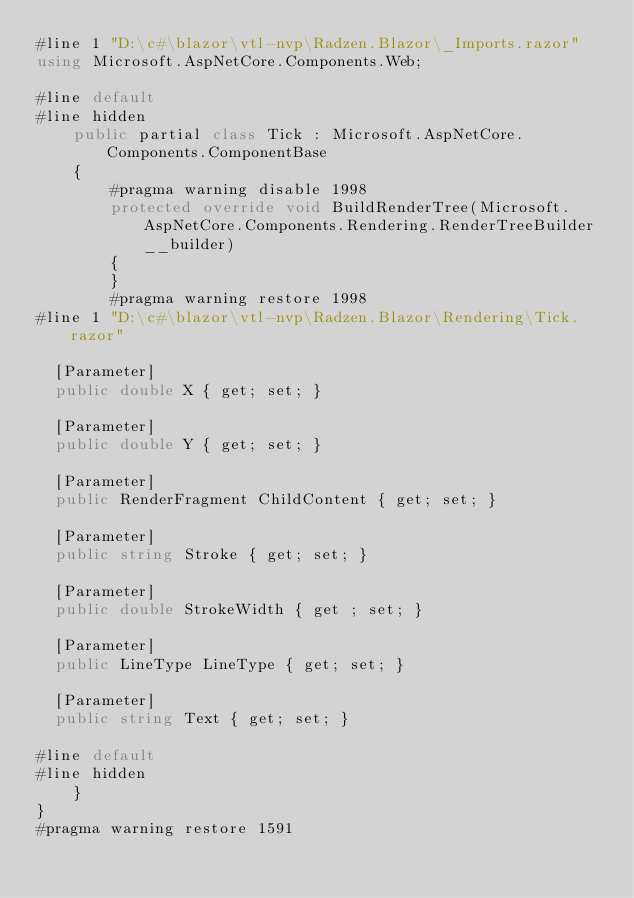<code> <loc_0><loc_0><loc_500><loc_500><_C#_>#line 1 "D:\c#\blazor\vtl-nvp\Radzen.Blazor\_Imports.razor"
using Microsoft.AspNetCore.Components.Web;

#line default
#line hidden
    public partial class Tick : Microsoft.AspNetCore.Components.ComponentBase
    {
        #pragma warning disable 1998
        protected override void BuildRenderTree(Microsoft.AspNetCore.Components.Rendering.RenderTreeBuilder __builder)
        {
        }
        #pragma warning restore 1998
#line 1 "D:\c#\blazor\vtl-nvp\Radzen.Blazor\Rendering\Tick.razor"
       
  [Parameter]
  public double X { get; set; }

  [Parameter]
  public double Y { get; set; }

  [Parameter]
  public RenderFragment ChildContent { get; set; }

  [Parameter]
  public string Stroke { get; set; }

  [Parameter]
  public double StrokeWidth { get ; set; }

  [Parameter]
  public LineType LineType { get; set; }

  [Parameter]
  public string Text { get; set; }

#line default
#line hidden
    }
}
#pragma warning restore 1591
</code> 